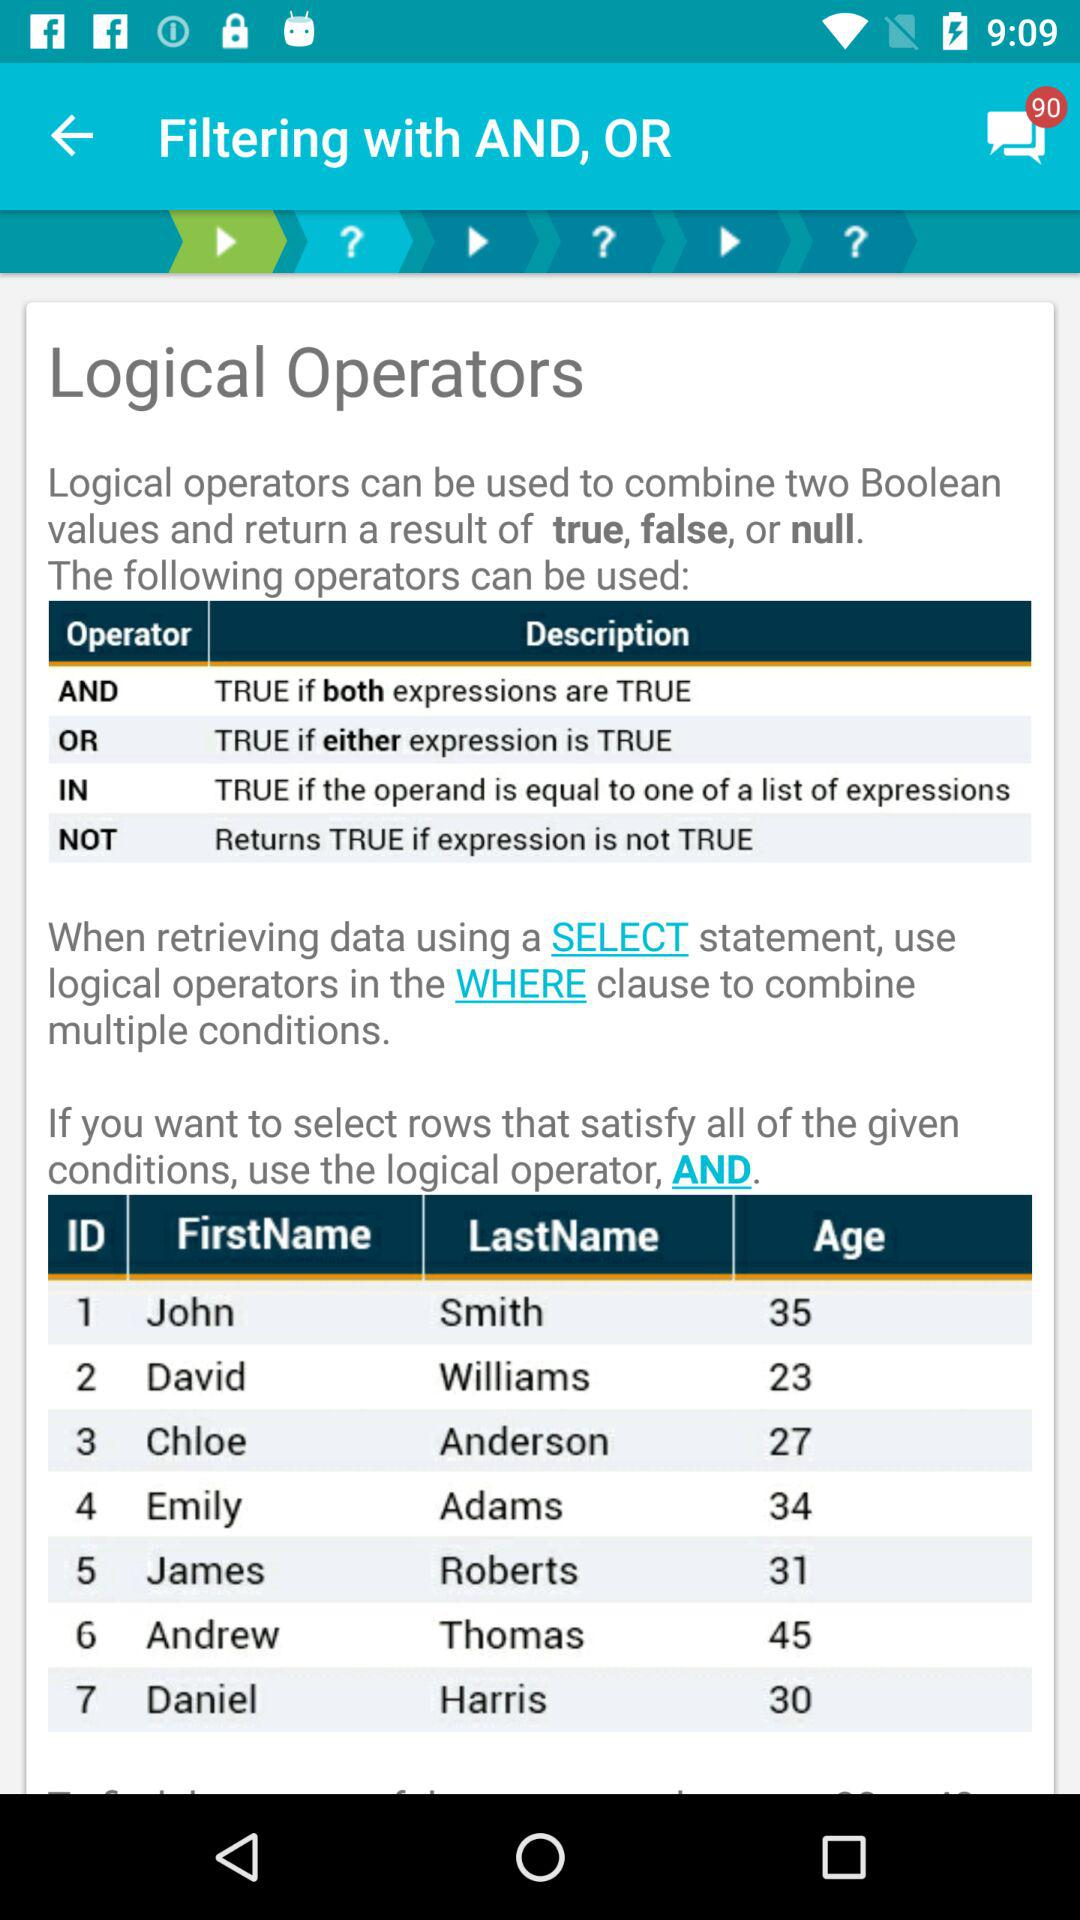What is the description of the NOT operator? The description of the NOT operator is "Returns TRUE if expression is not TRUE". 